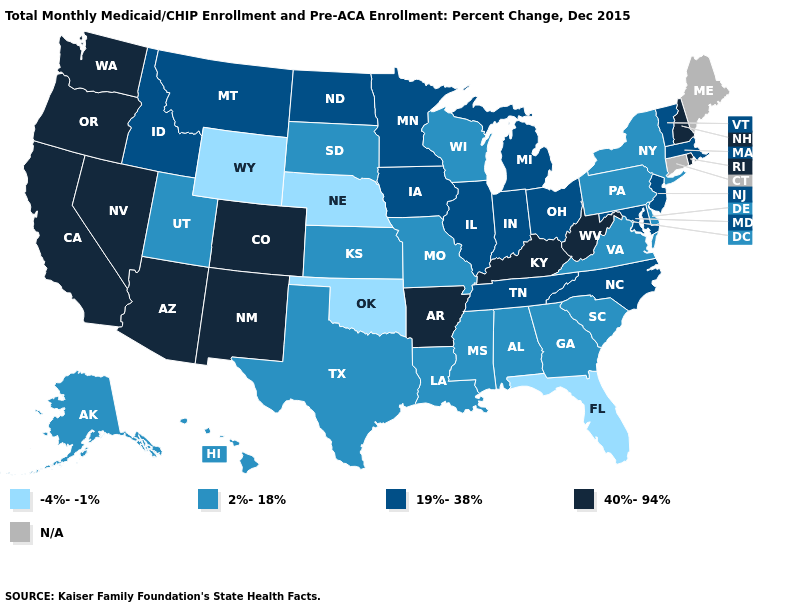What is the lowest value in the West?
Quick response, please. -4%--1%. Does Oklahoma have the lowest value in the USA?
Short answer required. Yes. What is the highest value in states that border Connecticut?
Short answer required. 40%-94%. What is the lowest value in the USA?
Answer briefly. -4%--1%. What is the value of Maine?
Answer briefly. N/A. Among the states that border South Dakota , does Minnesota have the lowest value?
Quick response, please. No. What is the value of Kentucky?
Write a very short answer. 40%-94%. What is the value of Missouri?
Concise answer only. 2%-18%. Does Arizona have the highest value in the West?
Concise answer only. Yes. What is the value of South Dakota?
Keep it brief. 2%-18%. What is the value of Nebraska?
Be succinct. -4%--1%. Name the states that have a value in the range 40%-94%?
Be succinct. Arizona, Arkansas, California, Colorado, Kentucky, Nevada, New Hampshire, New Mexico, Oregon, Rhode Island, Washington, West Virginia. Does Oklahoma have the highest value in the USA?
Give a very brief answer. No. 